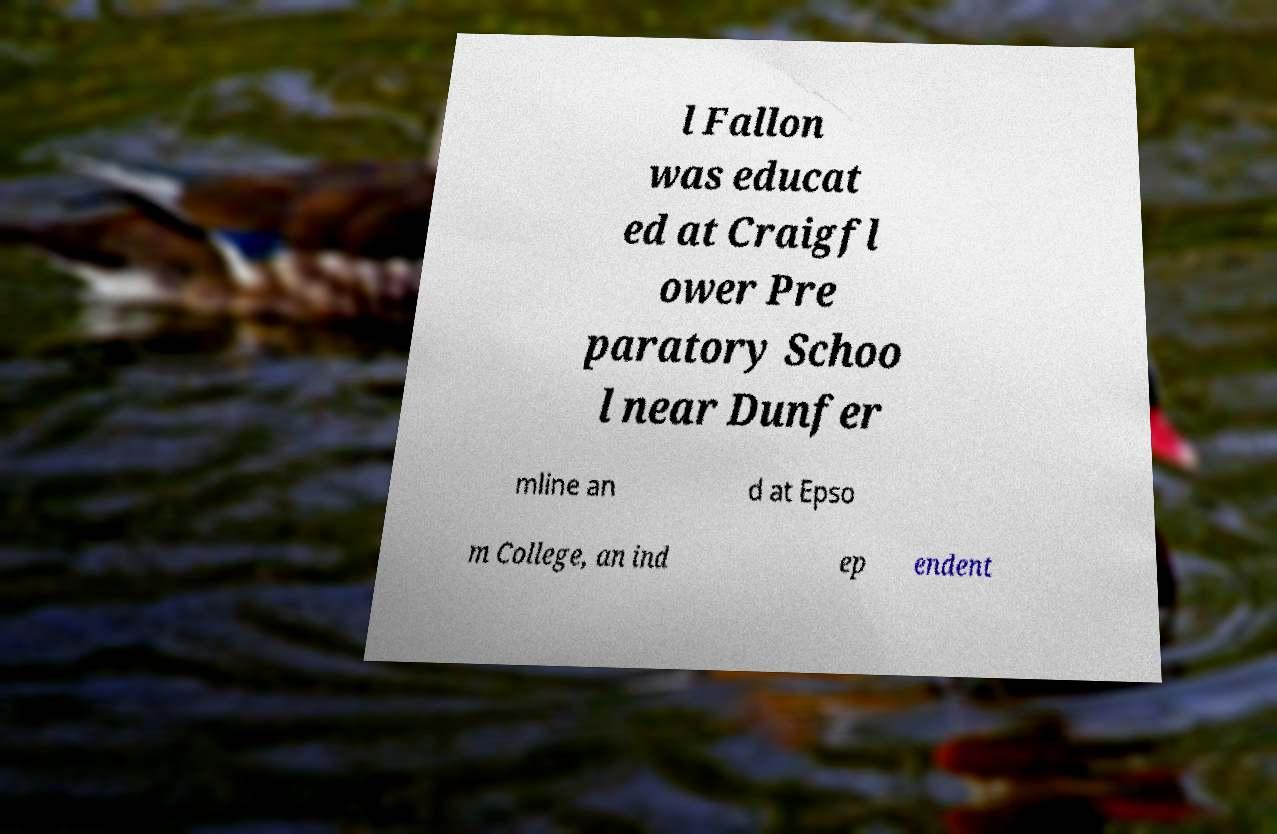Could you extract and type out the text from this image? l Fallon was educat ed at Craigfl ower Pre paratory Schoo l near Dunfer mline an d at Epso m College, an ind ep endent 